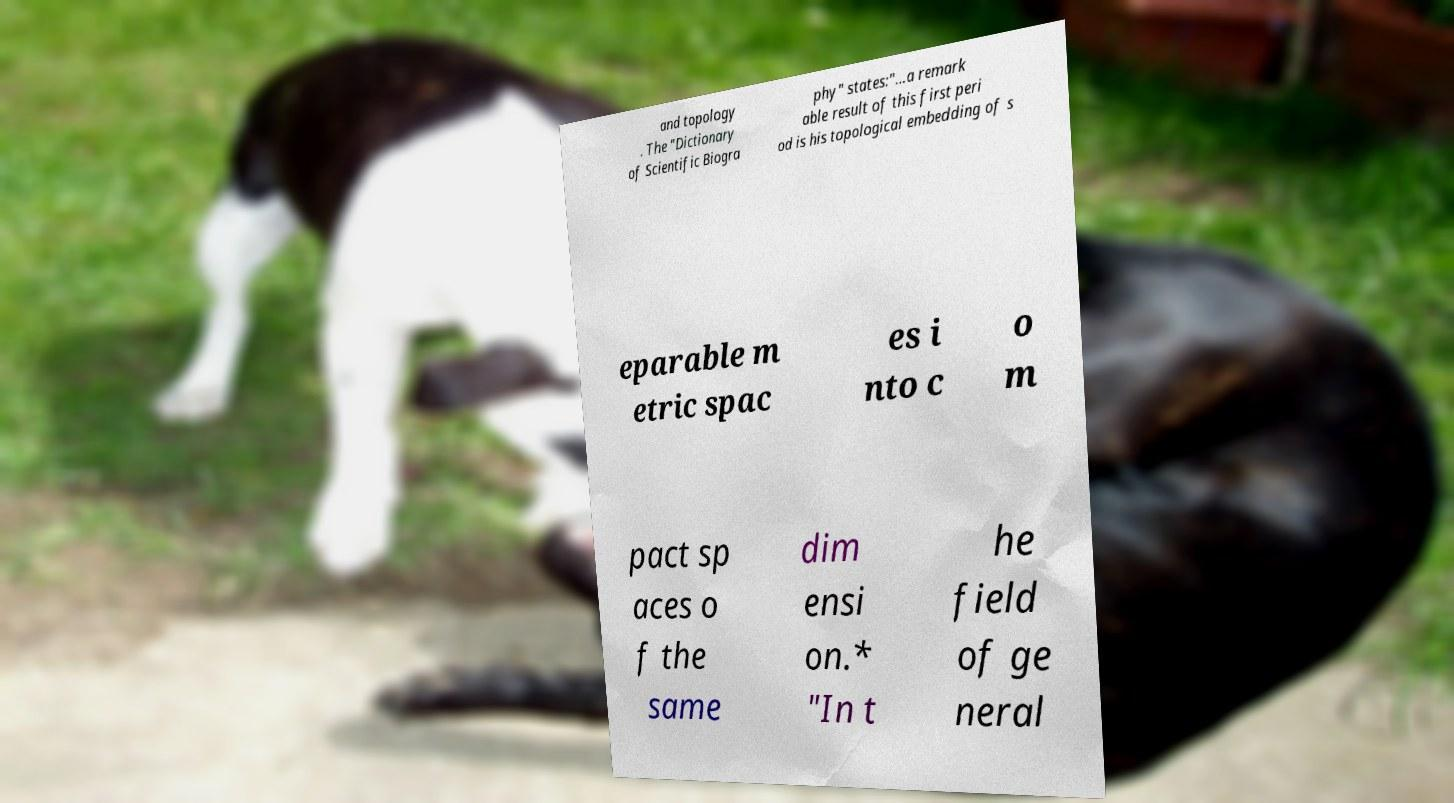Please identify and transcribe the text found in this image. and topology . The "Dictionary of Scientific Biogra phy" states:"...a remark able result of this first peri od is his topological embedding of s eparable m etric spac es i nto c o m pact sp aces o f the same dim ensi on.* "In t he field of ge neral 